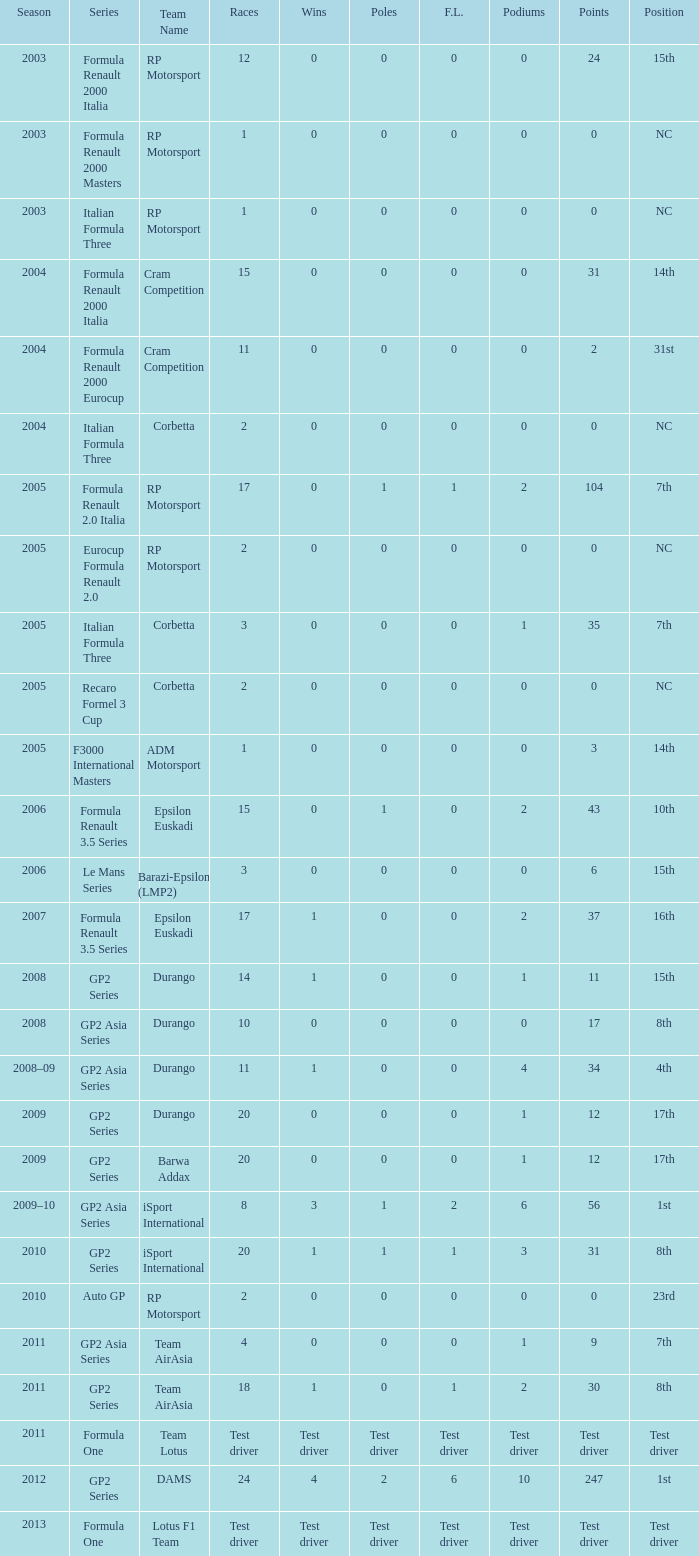What is the number of podiums with 0 wins and 6 points? 0.0. 